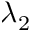<formula> <loc_0><loc_0><loc_500><loc_500>\lambda _ { 2 }</formula> 